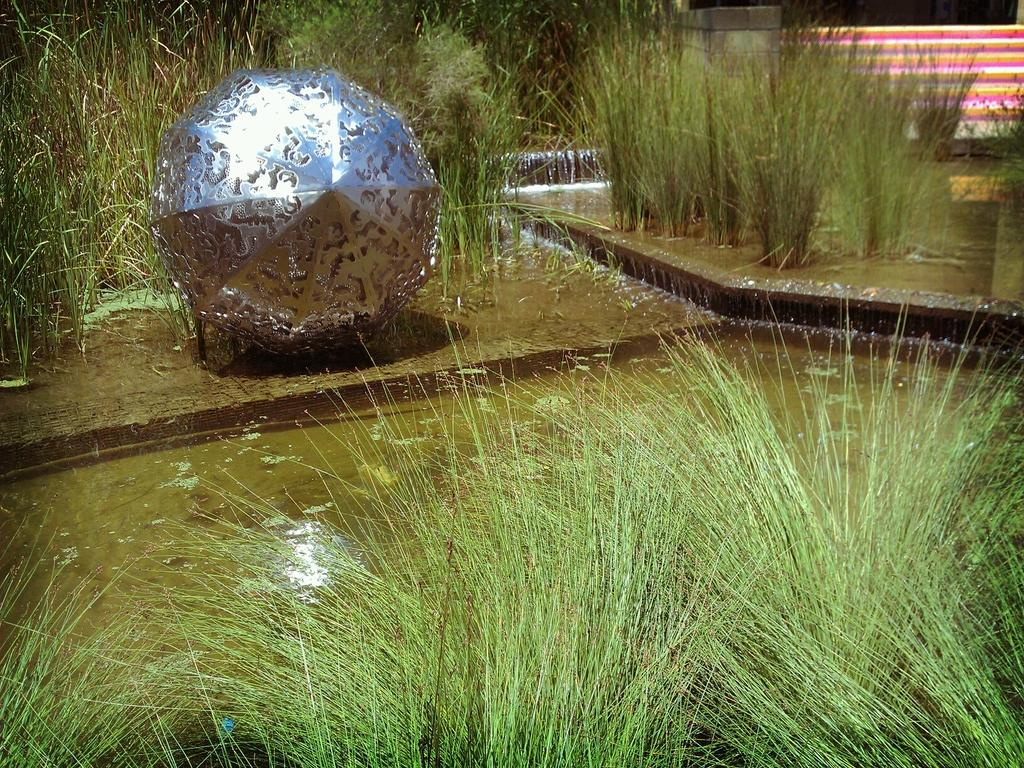What type of vegetation is present in the image? There is grass in the image, and it is green. What is happening with the water in the image? There is water flowing in the image. Can you describe the color and material of the object in the image? The object in the image is silver in color. What can be seen in the background of the image? In the background, there are colorful stairs. What type of belief is depicted in the image? There is no depiction of a belief in the image; it features grass, water, a silver object, and colorful stairs. How many clovers can be seen growing in the grass in the image? There are no clovers visible in the image; it only shows green grass. 